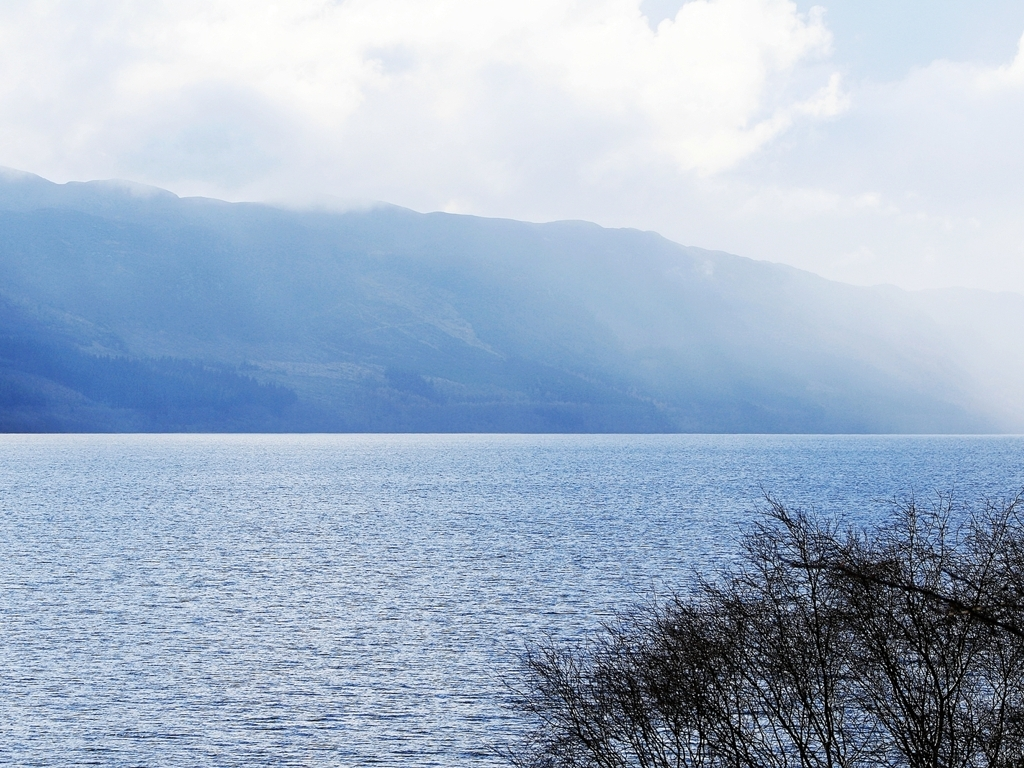Can you tell me more about the landscape featured in this image? The image showcases a serene lakeside view. In the foreground, one can see the rippling waters of the lake, and the middle ground is dominated by the silhouette of a tree branch. The background is filled with layers of mountain ranges fading into the distance, which creates a sense of depth. The haze gives the scene a mystical quality, although it slightly obscures the mountain detail. What could this image be used for? This image could be used for a variety of purposes, such as a backdrop for meditation and relaxation applications due to its tranquil nature. It could also be featured in travel brochures promoting lake destinations, or as a base for a landscape painting. Additionally, environmental campaigns could use it to showcase the beauty of natural landscapes and the importance of preserving them. 